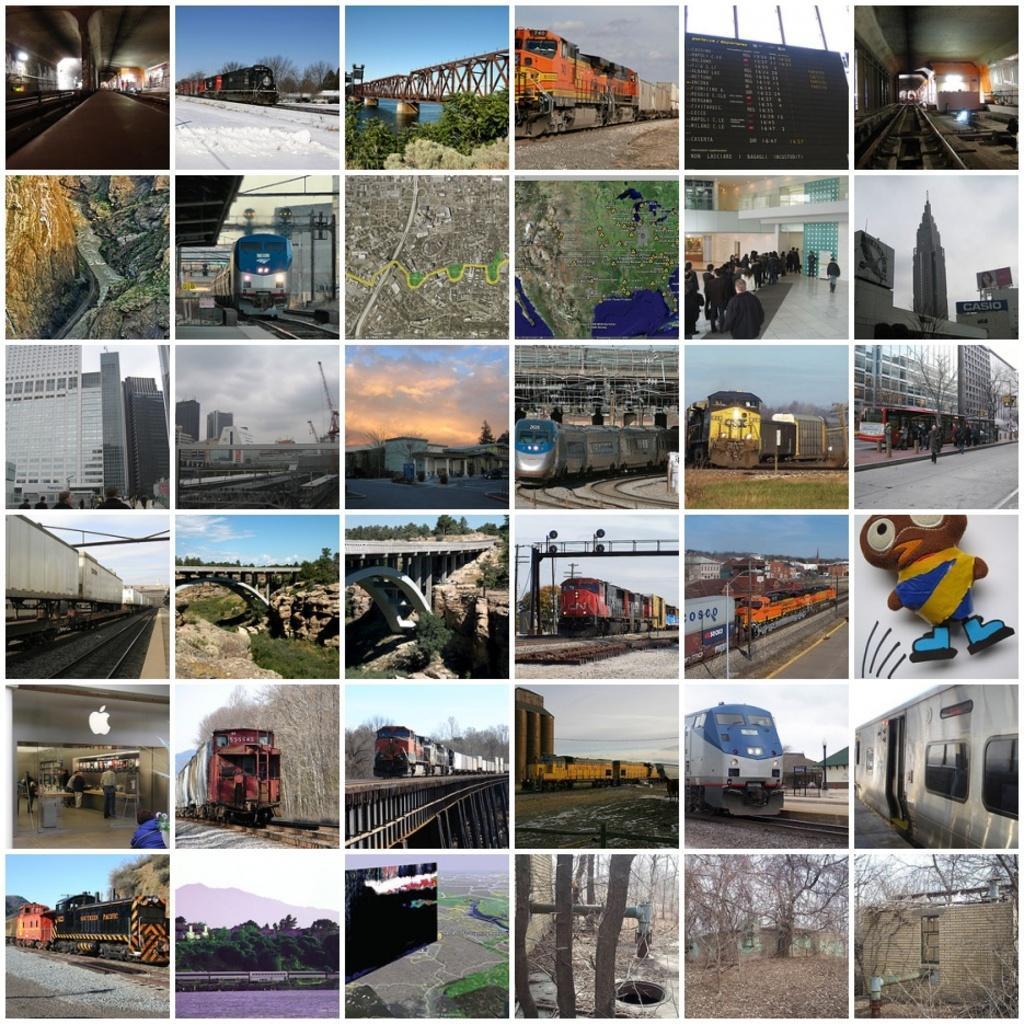Describe this image in one or two sentences. It is a collage image. There are pictures of trains, bridges, buildings, subways and houses. 